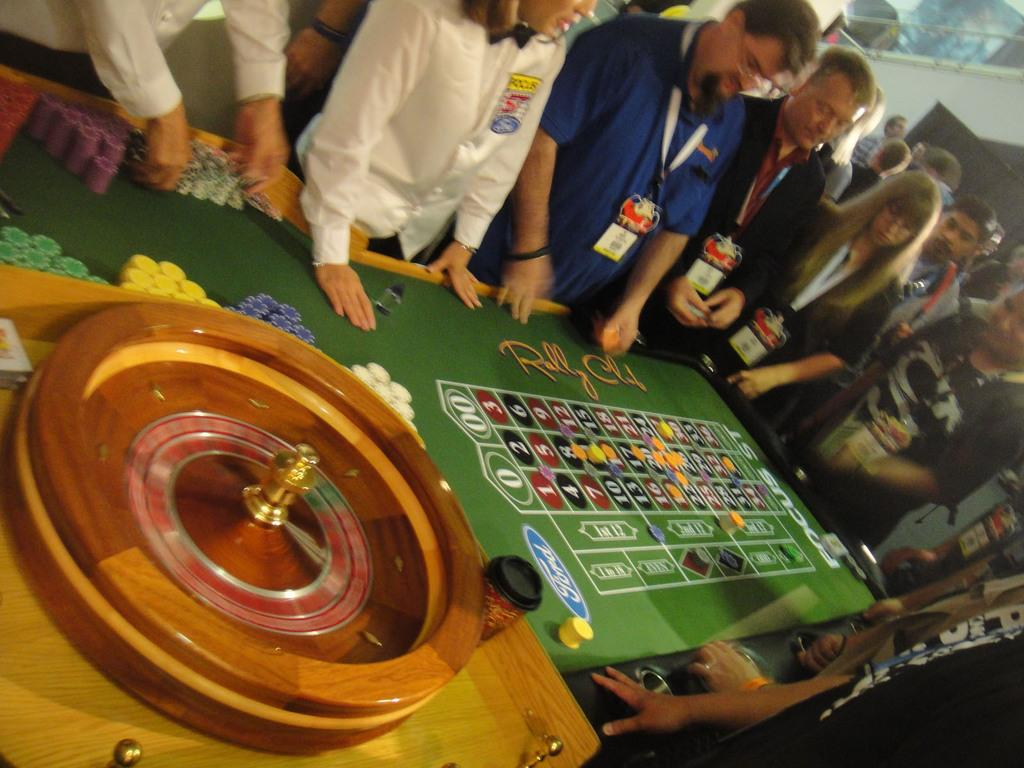What is the main object in the foreground of the image? There is a game board in the foreground of the image. What are the people in the background of the image doing? The people are standing in the background of the image and watching the game. What type of offer is being made by the dog in the image? There is no dog present in the image, so no offer can be made by a dog. 